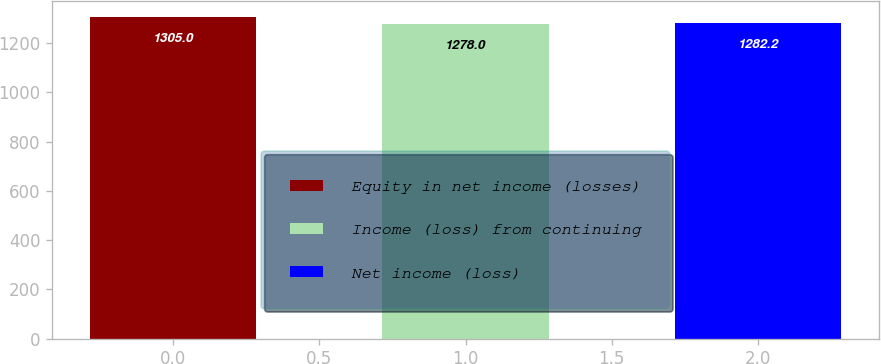Convert chart to OTSL. <chart><loc_0><loc_0><loc_500><loc_500><bar_chart><fcel>Equity in net income (losses)<fcel>Income (loss) from continuing<fcel>Net income (loss)<nl><fcel>1305<fcel>1278<fcel>1282.2<nl></chart> 